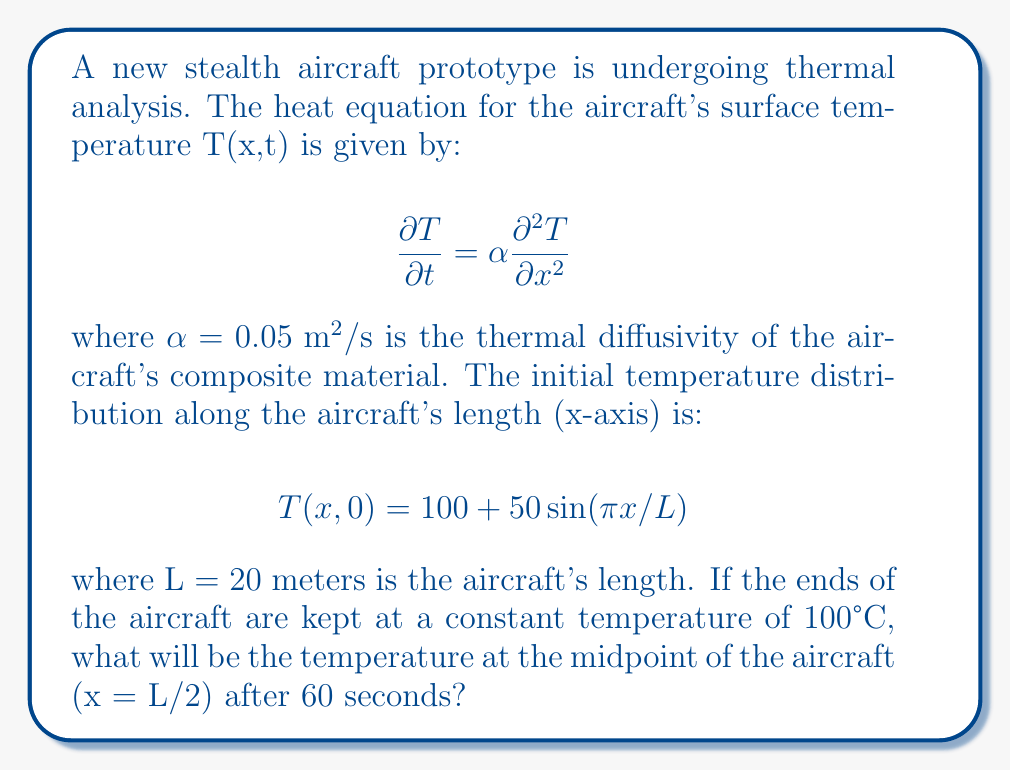Can you answer this question? To solve this problem, we need to use the separation of variables method for the heat equation with given boundary and initial conditions.

1) The general solution for the heat equation with these boundary conditions is:

   $$T(x,t) = 100 + \sum_{n=1}^{\infty} B_n \sin(\frac{n\pi x}{L})e^{-\alpha(\frac{n\pi}{L})^2t}$$

2) The initial condition is:

   $$T(x,0) = 100 + 50\sin(\pi x/L)$$

3) Comparing this with the general solution, we can see that only the n=1 term is present in the initial condition, with B₁ = 50 and all other B_n = 0.

4) Therefore, our specific solution is:

   $$T(x,t) = 100 + 50\sin(\frac{\pi x}{L})e^{-\alpha(\frac{\pi}{L})^2t}$$

5) We need to find T(L/2, 60). Substituting the values:

   $$T(L/2, 60) = 100 + 50\sin(\frac{\pi (L/2)}{L})e^{-0.05(\frac{\pi}{20})^2 * 60}$$

6) Simplify:
   
   $$T(L/2, 60) = 100 + 50\sin(\frac{\pi}{2})e^{-0.05(\frac{\pi}{20})^2 * 60}$$
   
   $$= 100 + 50 * 1 * e^{-0.0073725 * 60}$$
   
   $$= 100 + 50e^{-0.442350}$$

7) Calculate:

   $$= 100 + 50 * 0.642621$$
   
   $$= 100 + 32.13105$$
   
   $$= 132.13105$$

8) Rounding to two decimal places:

   $$T(L/2, 60) \approx 132.13°C$$
Answer: 132.13°C 